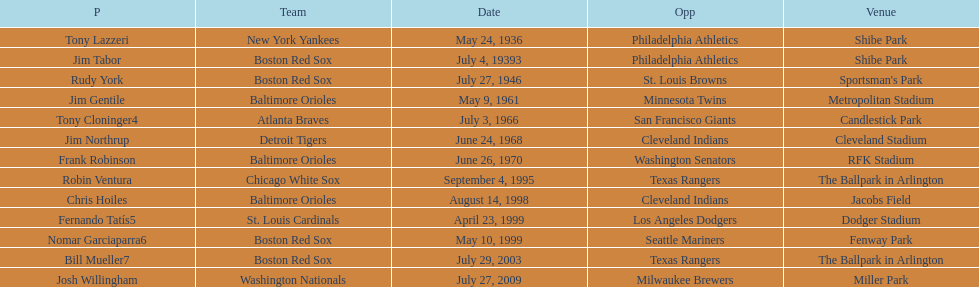Which teams faced off at miller park? Washington Nationals, Milwaukee Brewers. 